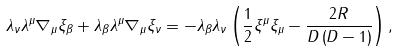<formula> <loc_0><loc_0><loc_500><loc_500>\lambda _ { \nu } \lambda ^ { \mu } \nabla _ { \mu } \xi _ { \beta } + \lambda _ { \beta } \lambda ^ { \mu } \nabla _ { \mu } \xi _ { \nu } = - \lambda _ { \beta } \lambda _ { \nu } \left ( \frac { 1 } { 2 } \xi ^ { \mu } \xi _ { \mu } - \frac { 2 R } { D \left ( D - 1 \right ) } \right ) ,</formula> 